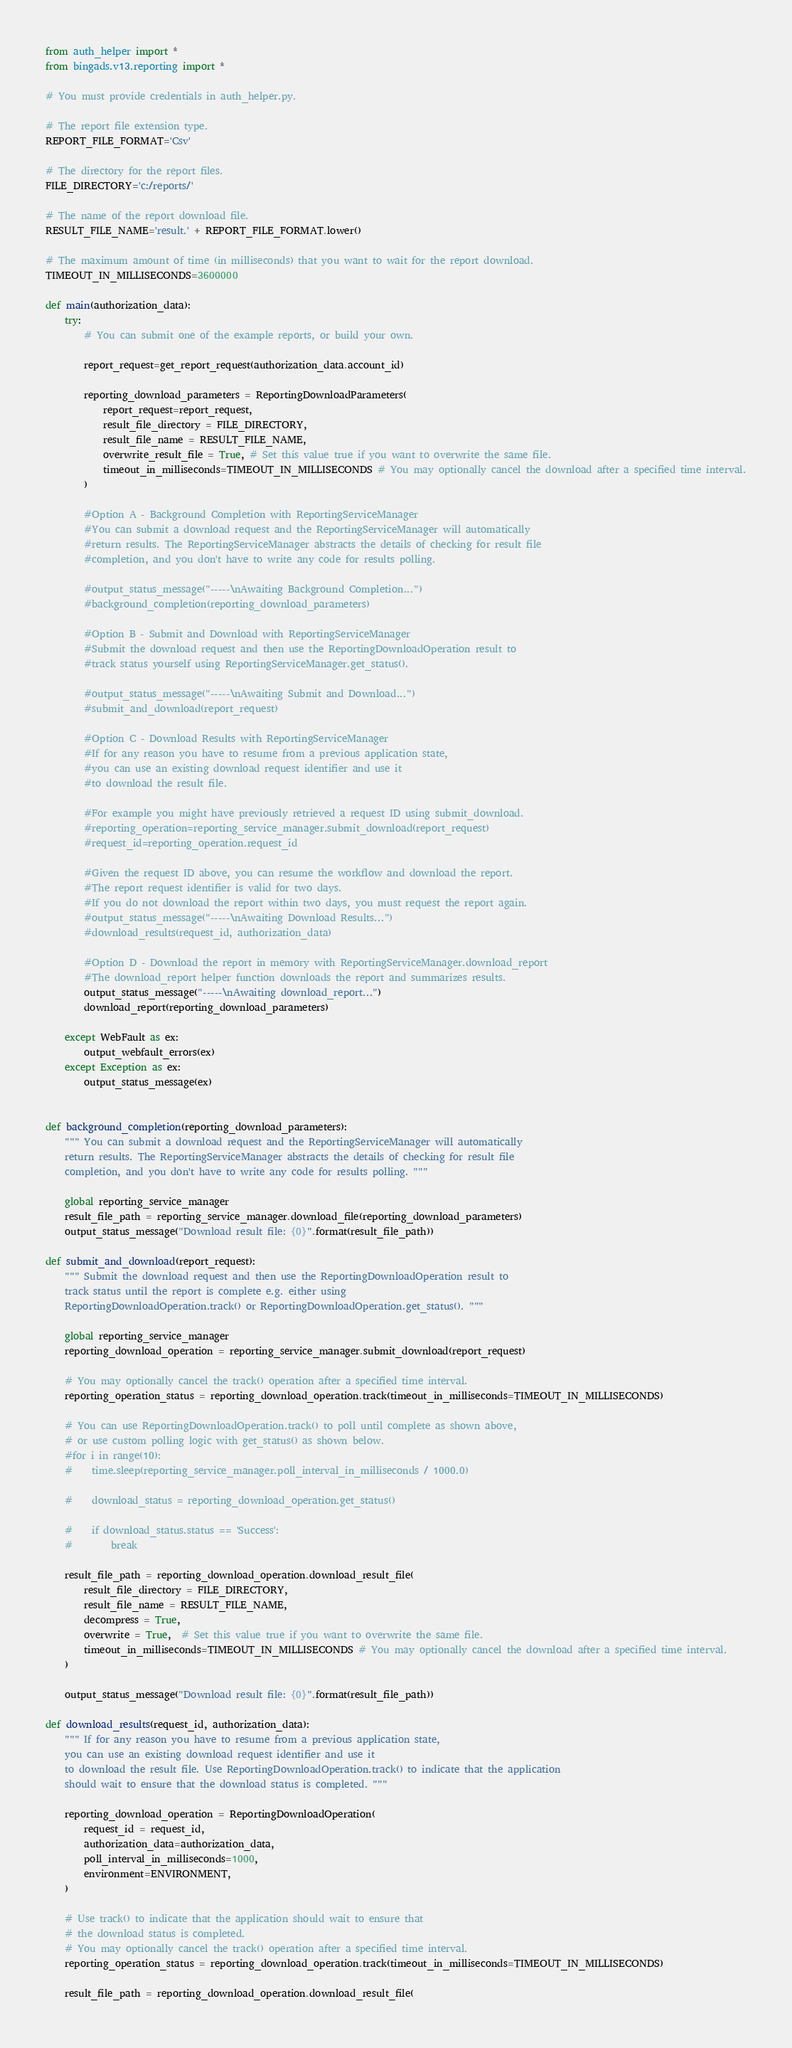Convert code to text. <code><loc_0><loc_0><loc_500><loc_500><_Python_>from auth_helper import *
from bingads.v13.reporting import *

# You must provide credentials in auth_helper.py.

# The report file extension type.
REPORT_FILE_FORMAT='Csv'

# The directory for the report files.
FILE_DIRECTORY='c:/reports/'

# The name of the report download file.
RESULT_FILE_NAME='result.' + REPORT_FILE_FORMAT.lower()

# The maximum amount of time (in milliseconds) that you want to wait for the report download.
TIMEOUT_IN_MILLISECONDS=3600000

def main(authorization_data):
    try:
        # You can submit one of the example reports, or build your own.

        report_request=get_report_request(authorization_data.account_id)
        
        reporting_download_parameters = ReportingDownloadParameters(
            report_request=report_request,
            result_file_directory = FILE_DIRECTORY, 
            result_file_name = RESULT_FILE_NAME, 
            overwrite_result_file = True, # Set this value true if you want to overwrite the same file.
            timeout_in_milliseconds=TIMEOUT_IN_MILLISECONDS # You may optionally cancel the download after a specified time interval.
        )

        #Option A - Background Completion with ReportingServiceManager
        #You can submit a download request and the ReportingServiceManager will automatically 
        #return results. The ReportingServiceManager abstracts the details of checking for result file 
        #completion, and you don't have to write any code for results polling.

        #output_status_message("-----\nAwaiting Background Completion...")
        #background_completion(reporting_download_parameters)

        #Option B - Submit and Download with ReportingServiceManager
        #Submit the download request and then use the ReportingDownloadOperation result to 
        #track status yourself using ReportingServiceManager.get_status().

        #output_status_message("-----\nAwaiting Submit and Download...")
        #submit_and_download(report_request)

        #Option C - Download Results with ReportingServiceManager
        #If for any reason you have to resume from a previous application state, 
        #you can use an existing download request identifier and use it 
        #to download the result file. 

        #For example you might have previously retrieved a request ID using submit_download.
        #reporting_operation=reporting_service_manager.submit_download(report_request)
        #request_id=reporting_operation.request_id

        #Given the request ID above, you can resume the workflow and download the report.
        #The report request identifier is valid for two days. 
        #If you do not download the report within two days, you must request the report again.
        #output_status_message("-----\nAwaiting Download Results...")
        #download_results(request_id, authorization_data)

        #Option D - Download the report in memory with ReportingServiceManager.download_report
        #The download_report helper function downloads the report and summarizes results.
        output_status_message("-----\nAwaiting download_report...")
        download_report(reporting_download_parameters)

    except WebFault as ex:
        output_webfault_errors(ex)
    except Exception as ex:
        output_status_message(ex)


def background_completion(reporting_download_parameters):
    """ You can submit a download request and the ReportingServiceManager will automatically 
    return results. The ReportingServiceManager abstracts the details of checking for result file 
    completion, and you don't have to write any code for results polling. """

    global reporting_service_manager
    result_file_path = reporting_service_manager.download_file(reporting_download_parameters)
    output_status_message("Download result file: {0}".format(result_file_path))

def submit_and_download(report_request):
    """ Submit the download request and then use the ReportingDownloadOperation result to 
    track status until the report is complete e.g. either using
    ReportingDownloadOperation.track() or ReportingDownloadOperation.get_status(). """

    global reporting_service_manager
    reporting_download_operation = reporting_service_manager.submit_download(report_request)

    # You may optionally cancel the track() operation after a specified time interval.
    reporting_operation_status = reporting_download_operation.track(timeout_in_milliseconds=TIMEOUT_IN_MILLISECONDS)

    # You can use ReportingDownloadOperation.track() to poll until complete as shown above, 
    # or use custom polling logic with get_status() as shown below.
    #for i in range(10):
    #    time.sleep(reporting_service_manager.poll_interval_in_milliseconds / 1000.0)

    #    download_status = reporting_download_operation.get_status()
        
    #    if download_status.status == 'Success':
    #        break
    
    result_file_path = reporting_download_operation.download_result_file(
        result_file_directory = FILE_DIRECTORY, 
        result_file_name = RESULT_FILE_NAME, 
        decompress = True, 
        overwrite = True,  # Set this value true if you want to overwrite the same file.
        timeout_in_milliseconds=TIMEOUT_IN_MILLISECONDS # You may optionally cancel the download after a specified time interval.
    )
    
    output_status_message("Download result file: {0}".format(result_file_path))

def download_results(request_id, authorization_data):
    """ If for any reason you have to resume from a previous application state, 
    you can use an existing download request identifier and use it 
    to download the result file. Use ReportingDownloadOperation.track() to indicate that the application 
    should wait to ensure that the download status is completed. """
    
    reporting_download_operation = ReportingDownloadOperation(
        request_id = request_id, 
        authorization_data=authorization_data, 
        poll_interval_in_milliseconds=1000, 
        environment=ENVIRONMENT,
    )

    # Use track() to indicate that the application should wait to ensure that 
    # the download status is completed.
    # You may optionally cancel the track() operation after a specified time interval.
    reporting_operation_status = reporting_download_operation.track(timeout_in_milliseconds=TIMEOUT_IN_MILLISECONDS)
    
    result_file_path = reporting_download_operation.download_result_file(</code> 